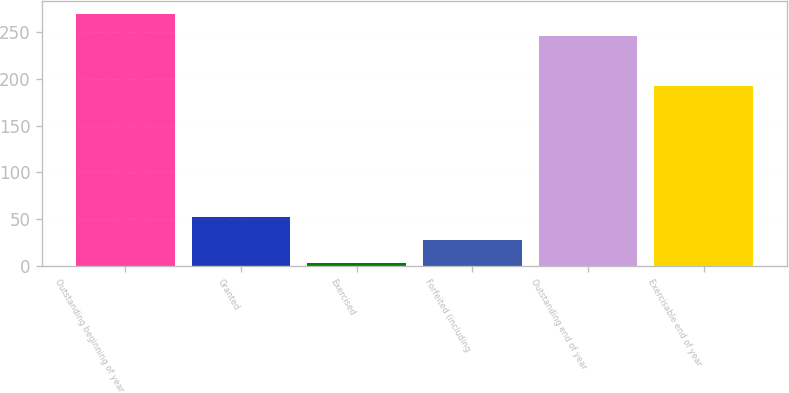<chart> <loc_0><loc_0><loc_500><loc_500><bar_chart><fcel>Outstanding beginning of year<fcel>Granted<fcel>Exercised<fcel>Forfeited (including<fcel>Outstanding end of year<fcel>Exercisable end of year<nl><fcel>269.37<fcel>52.04<fcel>3.7<fcel>27.87<fcel>245.2<fcel>191.9<nl></chart> 